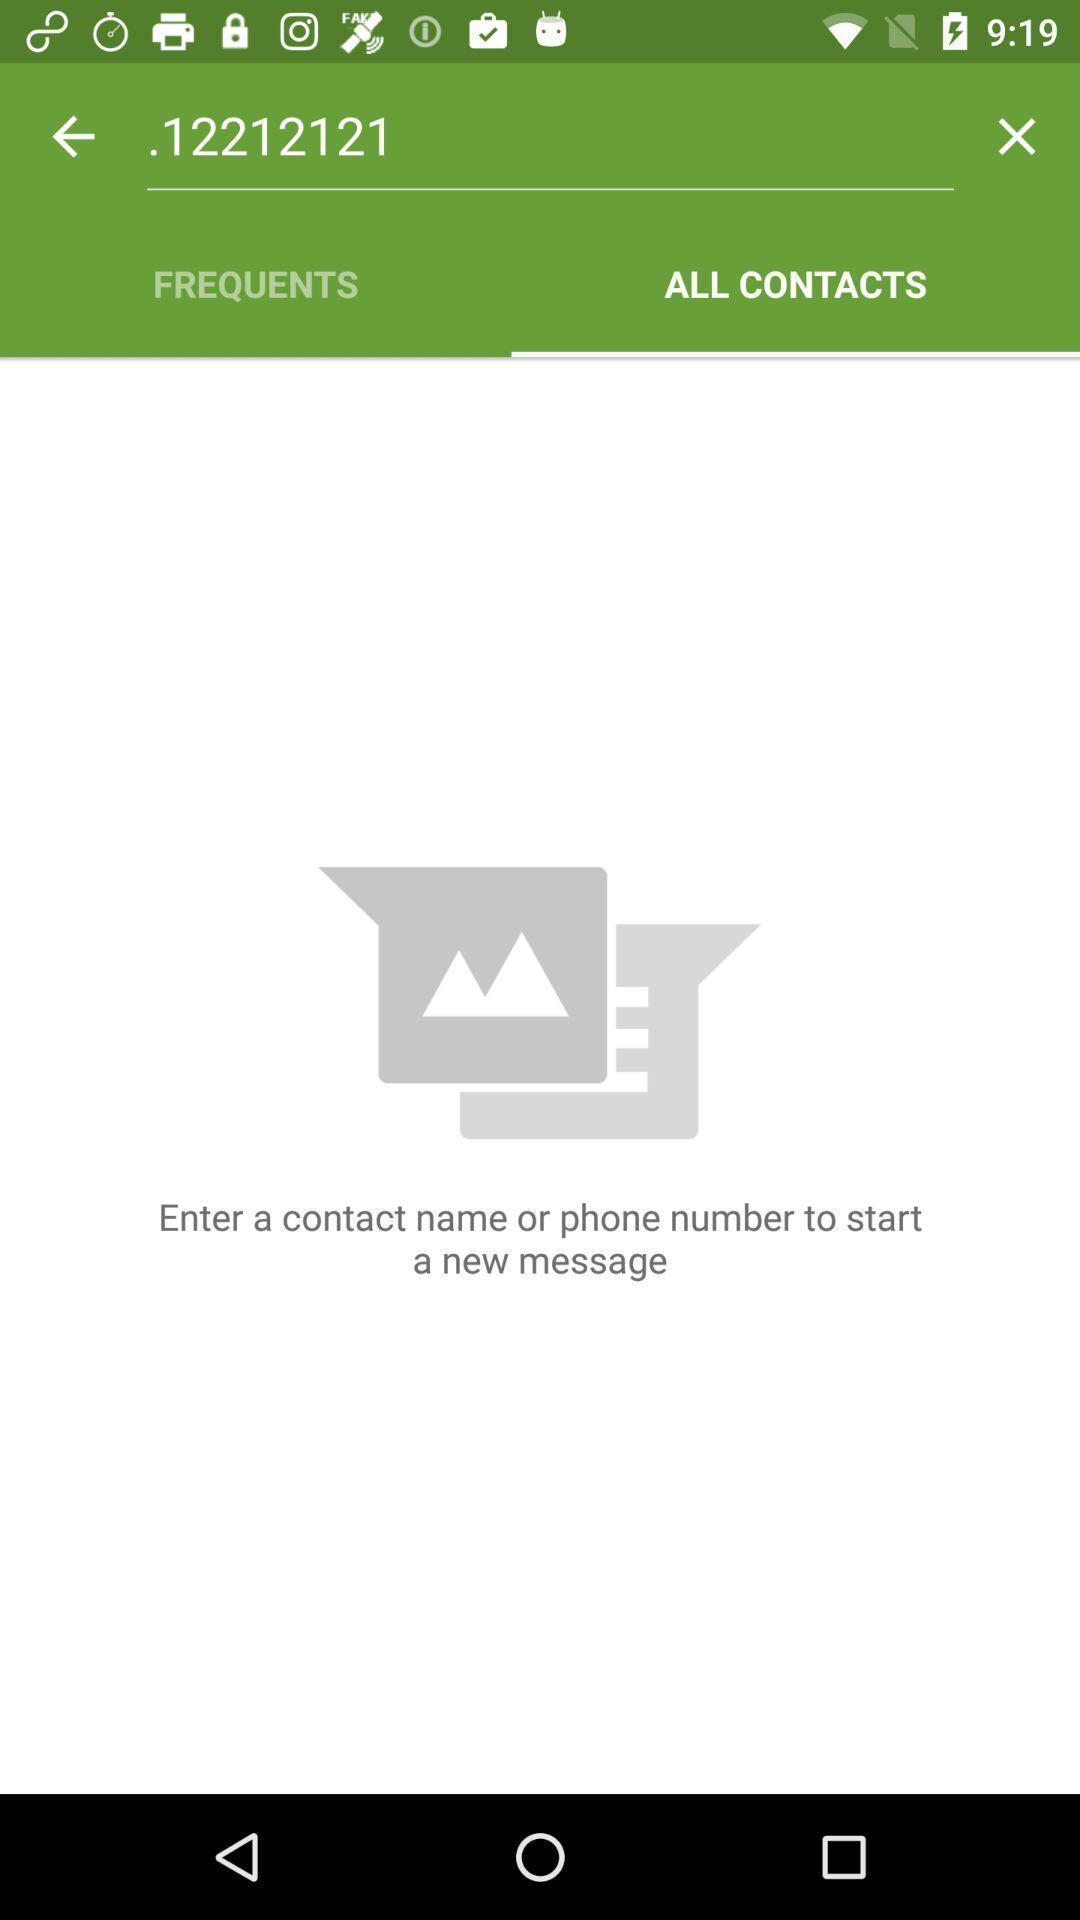Summarize the information in this screenshot. Search page for contacts in the audio app. 